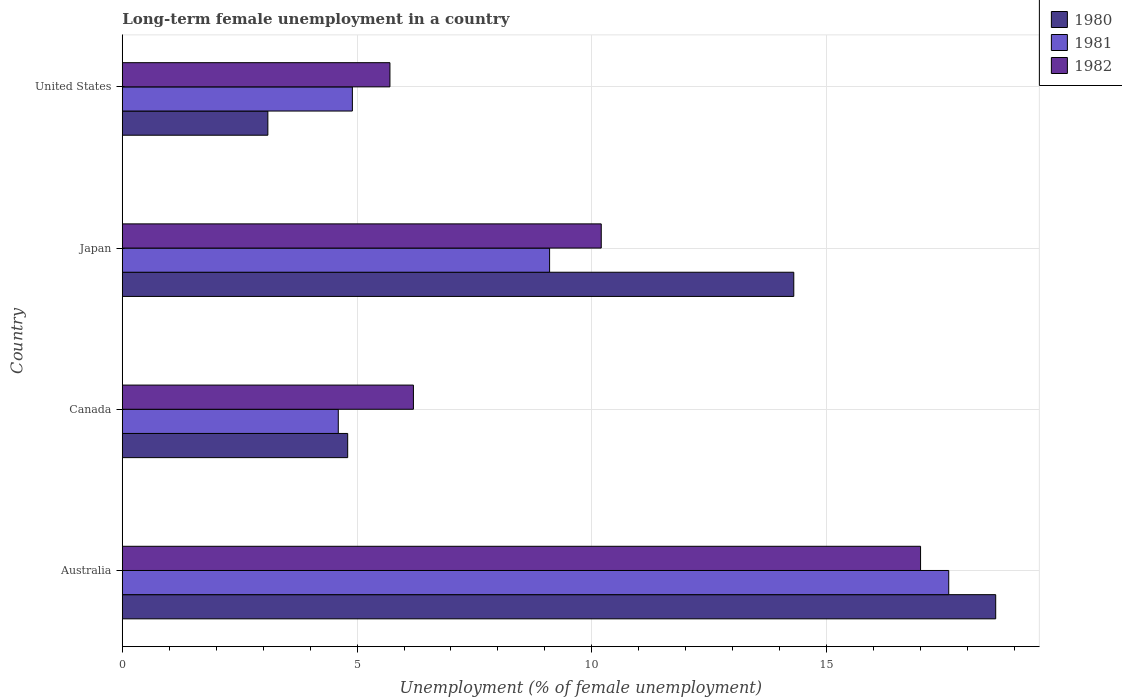How many different coloured bars are there?
Make the answer very short. 3. What is the label of the 4th group of bars from the top?
Your answer should be very brief. Australia. What is the percentage of long-term unemployed female population in 1980 in Japan?
Give a very brief answer. 14.3. Across all countries, what is the maximum percentage of long-term unemployed female population in 1980?
Your response must be concise. 18.6. Across all countries, what is the minimum percentage of long-term unemployed female population in 1981?
Give a very brief answer. 4.6. In which country was the percentage of long-term unemployed female population in 1980 maximum?
Ensure brevity in your answer.  Australia. In which country was the percentage of long-term unemployed female population in 1982 minimum?
Provide a succinct answer. United States. What is the total percentage of long-term unemployed female population in 1982 in the graph?
Provide a succinct answer. 39.1. What is the difference between the percentage of long-term unemployed female population in 1980 in Australia and that in United States?
Your answer should be compact. 15.5. What is the difference between the percentage of long-term unemployed female population in 1980 in Canada and the percentage of long-term unemployed female population in 1981 in Australia?
Your answer should be very brief. -12.8. What is the average percentage of long-term unemployed female population in 1982 per country?
Give a very brief answer. 9.77. What is the difference between the percentage of long-term unemployed female population in 1980 and percentage of long-term unemployed female population in 1981 in Canada?
Your answer should be compact. 0.2. In how many countries, is the percentage of long-term unemployed female population in 1981 greater than 4 %?
Your response must be concise. 4. What is the ratio of the percentage of long-term unemployed female population in 1982 in Japan to that in United States?
Offer a terse response. 1.79. What is the difference between the highest and the second highest percentage of long-term unemployed female population in 1982?
Make the answer very short. 6.8. What is the difference between the highest and the lowest percentage of long-term unemployed female population in 1982?
Your response must be concise. 11.3. What does the 2nd bar from the top in Canada represents?
Make the answer very short. 1981. What does the 1st bar from the bottom in Japan represents?
Keep it short and to the point. 1980. How many bars are there?
Offer a very short reply. 12. What is the difference between two consecutive major ticks on the X-axis?
Ensure brevity in your answer.  5. Does the graph contain any zero values?
Ensure brevity in your answer.  No. Does the graph contain grids?
Give a very brief answer. Yes. Where does the legend appear in the graph?
Offer a very short reply. Top right. How many legend labels are there?
Provide a short and direct response. 3. What is the title of the graph?
Provide a short and direct response. Long-term female unemployment in a country. What is the label or title of the X-axis?
Offer a terse response. Unemployment (% of female unemployment). What is the Unemployment (% of female unemployment) of 1980 in Australia?
Your answer should be very brief. 18.6. What is the Unemployment (% of female unemployment) in 1981 in Australia?
Provide a short and direct response. 17.6. What is the Unemployment (% of female unemployment) in 1980 in Canada?
Your answer should be very brief. 4.8. What is the Unemployment (% of female unemployment) of 1981 in Canada?
Your answer should be compact. 4.6. What is the Unemployment (% of female unemployment) of 1982 in Canada?
Keep it short and to the point. 6.2. What is the Unemployment (% of female unemployment) of 1980 in Japan?
Offer a terse response. 14.3. What is the Unemployment (% of female unemployment) of 1981 in Japan?
Provide a short and direct response. 9.1. What is the Unemployment (% of female unemployment) in 1982 in Japan?
Give a very brief answer. 10.2. What is the Unemployment (% of female unemployment) of 1980 in United States?
Provide a succinct answer. 3.1. What is the Unemployment (% of female unemployment) of 1981 in United States?
Provide a succinct answer. 4.9. What is the Unemployment (% of female unemployment) in 1982 in United States?
Your response must be concise. 5.7. Across all countries, what is the maximum Unemployment (% of female unemployment) of 1980?
Provide a succinct answer. 18.6. Across all countries, what is the maximum Unemployment (% of female unemployment) of 1981?
Ensure brevity in your answer.  17.6. Across all countries, what is the minimum Unemployment (% of female unemployment) of 1980?
Ensure brevity in your answer.  3.1. Across all countries, what is the minimum Unemployment (% of female unemployment) of 1981?
Ensure brevity in your answer.  4.6. Across all countries, what is the minimum Unemployment (% of female unemployment) of 1982?
Offer a very short reply. 5.7. What is the total Unemployment (% of female unemployment) of 1980 in the graph?
Provide a short and direct response. 40.8. What is the total Unemployment (% of female unemployment) of 1981 in the graph?
Offer a very short reply. 36.2. What is the total Unemployment (% of female unemployment) in 1982 in the graph?
Your answer should be very brief. 39.1. What is the difference between the Unemployment (% of female unemployment) of 1980 in Australia and that in Canada?
Keep it short and to the point. 13.8. What is the difference between the Unemployment (% of female unemployment) in 1980 in Australia and that in Japan?
Your answer should be very brief. 4.3. What is the difference between the Unemployment (% of female unemployment) of 1981 in Australia and that in Japan?
Provide a succinct answer. 8.5. What is the difference between the Unemployment (% of female unemployment) of 1981 in Australia and that in United States?
Ensure brevity in your answer.  12.7. What is the difference between the Unemployment (% of female unemployment) in 1981 in Canada and that in Japan?
Offer a terse response. -4.5. What is the difference between the Unemployment (% of female unemployment) in 1982 in Canada and that in Japan?
Make the answer very short. -4. What is the difference between the Unemployment (% of female unemployment) in 1981 in Canada and that in United States?
Your answer should be compact. -0.3. What is the difference between the Unemployment (% of female unemployment) in 1982 in Canada and that in United States?
Ensure brevity in your answer.  0.5. What is the difference between the Unemployment (% of female unemployment) of 1980 in Japan and that in United States?
Provide a short and direct response. 11.2. What is the difference between the Unemployment (% of female unemployment) of 1980 in Australia and the Unemployment (% of female unemployment) of 1982 in Canada?
Make the answer very short. 12.4. What is the difference between the Unemployment (% of female unemployment) in 1980 in Australia and the Unemployment (% of female unemployment) in 1981 in Japan?
Offer a terse response. 9.5. What is the difference between the Unemployment (% of female unemployment) in 1980 in Australia and the Unemployment (% of female unemployment) in 1981 in United States?
Ensure brevity in your answer.  13.7. What is the difference between the Unemployment (% of female unemployment) in 1981 in Australia and the Unemployment (% of female unemployment) in 1982 in United States?
Your response must be concise. 11.9. What is the difference between the Unemployment (% of female unemployment) in 1980 in Canada and the Unemployment (% of female unemployment) in 1981 in Japan?
Make the answer very short. -4.3. What is the difference between the Unemployment (% of female unemployment) of 1980 in Canada and the Unemployment (% of female unemployment) of 1982 in Japan?
Your answer should be very brief. -5.4. What is the difference between the Unemployment (% of female unemployment) of 1980 in Canada and the Unemployment (% of female unemployment) of 1982 in United States?
Offer a terse response. -0.9. What is the difference between the Unemployment (% of female unemployment) in 1980 in Japan and the Unemployment (% of female unemployment) in 1981 in United States?
Provide a succinct answer. 9.4. What is the difference between the Unemployment (% of female unemployment) in 1980 in Japan and the Unemployment (% of female unemployment) in 1982 in United States?
Your answer should be compact. 8.6. What is the difference between the Unemployment (% of female unemployment) of 1981 in Japan and the Unemployment (% of female unemployment) of 1982 in United States?
Make the answer very short. 3.4. What is the average Unemployment (% of female unemployment) of 1980 per country?
Ensure brevity in your answer.  10.2. What is the average Unemployment (% of female unemployment) in 1981 per country?
Your answer should be compact. 9.05. What is the average Unemployment (% of female unemployment) in 1982 per country?
Offer a terse response. 9.78. What is the difference between the Unemployment (% of female unemployment) in 1980 and Unemployment (% of female unemployment) in 1981 in Australia?
Make the answer very short. 1. What is the difference between the Unemployment (% of female unemployment) of 1981 and Unemployment (% of female unemployment) of 1982 in Australia?
Offer a terse response. 0.6. What is the difference between the Unemployment (% of female unemployment) of 1980 and Unemployment (% of female unemployment) of 1981 in Canada?
Provide a short and direct response. 0.2. What is the difference between the Unemployment (% of female unemployment) in 1980 and Unemployment (% of female unemployment) in 1982 in Canada?
Give a very brief answer. -1.4. What is the difference between the Unemployment (% of female unemployment) of 1981 and Unemployment (% of female unemployment) of 1982 in Canada?
Your answer should be compact. -1.6. What is the difference between the Unemployment (% of female unemployment) in 1980 and Unemployment (% of female unemployment) in 1981 in Japan?
Provide a succinct answer. 5.2. What is the difference between the Unemployment (% of female unemployment) of 1981 and Unemployment (% of female unemployment) of 1982 in Japan?
Your answer should be very brief. -1.1. What is the difference between the Unemployment (% of female unemployment) of 1980 and Unemployment (% of female unemployment) of 1981 in United States?
Your answer should be very brief. -1.8. What is the difference between the Unemployment (% of female unemployment) of 1980 and Unemployment (% of female unemployment) of 1982 in United States?
Provide a short and direct response. -2.6. What is the difference between the Unemployment (% of female unemployment) of 1981 and Unemployment (% of female unemployment) of 1982 in United States?
Provide a short and direct response. -0.8. What is the ratio of the Unemployment (% of female unemployment) in 1980 in Australia to that in Canada?
Your answer should be very brief. 3.88. What is the ratio of the Unemployment (% of female unemployment) in 1981 in Australia to that in Canada?
Your answer should be very brief. 3.83. What is the ratio of the Unemployment (% of female unemployment) of 1982 in Australia to that in Canada?
Make the answer very short. 2.74. What is the ratio of the Unemployment (% of female unemployment) of 1980 in Australia to that in Japan?
Make the answer very short. 1.3. What is the ratio of the Unemployment (% of female unemployment) in 1981 in Australia to that in Japan?
Offer a terse response. 1.93. What is the ratio of the Unemployment (% of female unemployment) of 1982 in Australia to that in Japan?
Make the answer very short. 1.67. What is the ratio of the Unemployment (% of female unemployment) in 1980 in Australia to that in United States?
Keep it short and to the point. 6. What is the ratio of the Unemployment (% of female unemployment) in 1981 in Australia to that in United States?
Make the answer very short. 3.59. What is the ratio of the Unemployment (% of female unemployment) of 1982 in Australia to that in United States?
Your response must be concise. 2.98. What is the ratio of the Unemployment (% of female unemployment) of 1980 in Canada to that in Japan?
Your answer should be compact. 0.34. What is the ratio of the Unemployment (% of female unemployment) of 1981 in Canada to that in Japan?
Your answer should be very brief. 0.51. What is the ratio of the Unemployment (% of female unemployment) of 1982 in Canada to that in Japan?
Your answer should be compact. 0.61. What is the ratio of the Unemployment (% of female unemployment) of 1980 in Canada to that in United States?
Offer a terse response. 1.55. What is the ratio of the Unemployment (% of female unemployment) in 1981 in Canada to that in United States?
Keep it short and to the point. 0.94. What is the ratio of the Unemployment (% of female unemployment) of 1982 in Canada to that in United States?
Ensure brevity in your answer.  1.09. What is the ratio of the Unemployment (% of female unemployment) in 1980 in Japan to that in United States?
Provide a short and direct response. 4.61. What is the ratio of the Unemployment (% of female unemployment) in 1981 in Japan to that in United States?
Provide a succinct answer. 1.86. What is the ratio of the Unemployment (% of female unemployment) of 1982 in Japan to that in United States?
Keep it short and to the point. 1.79. What is the difference between the highest and the lowest Unemployment (% of female unemployment) of 1980?
Your answer should be very brief. 15.5. What is the difference between the highest and the lowest Unemployment (% of female unemployment) of 1981?
Make the answer very short. 13. 